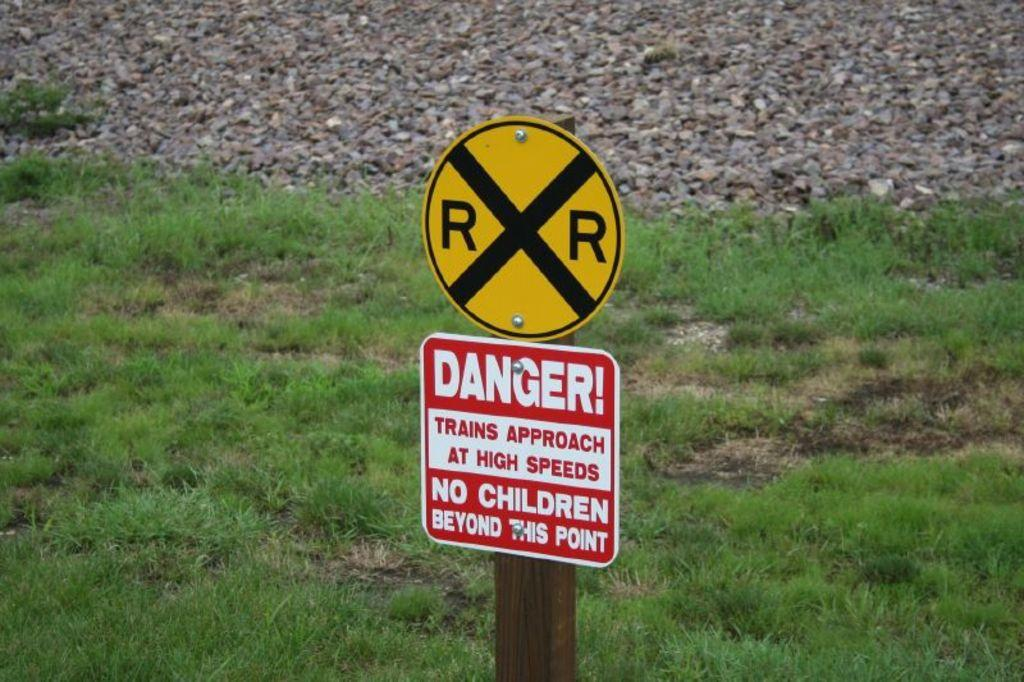<image>
Create a compact narrative representing the image presented. A railroad crossing sign has a danger sign below it forbidding children to pass. 